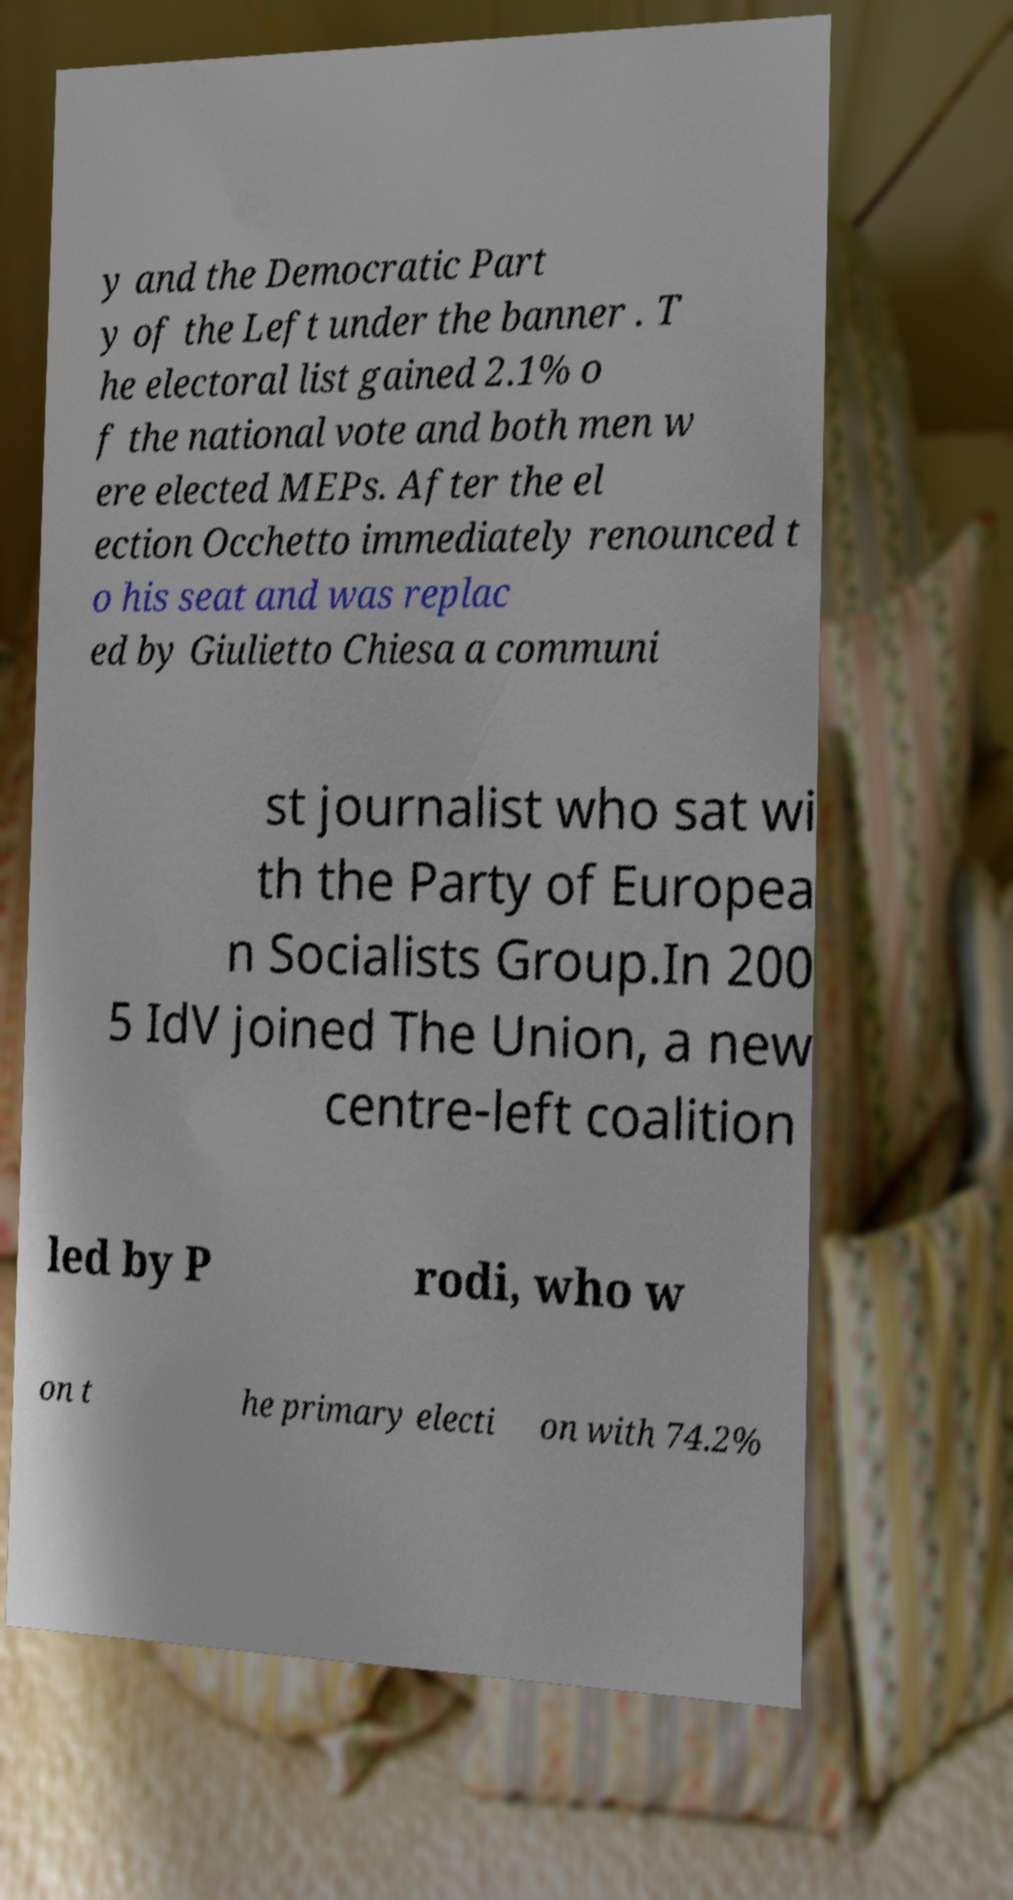Can you accurately transcribe the text from the provided image for me? y and the Democratic Part y of the Left under the banner . T he electoral list gained 2.1% o f the national vote and both men w ere elected MEPs. After the el ection Occhetto immediately renounced t o his seat and was replac ed by Giulietto Chiesa a communi st journalist who sat wi th the Party of Europea n Socialists Group.In 200 5 IdV joined The Union, a new centre-left coalition led by P rodi, who w on t he primary electi on with 74.2% 